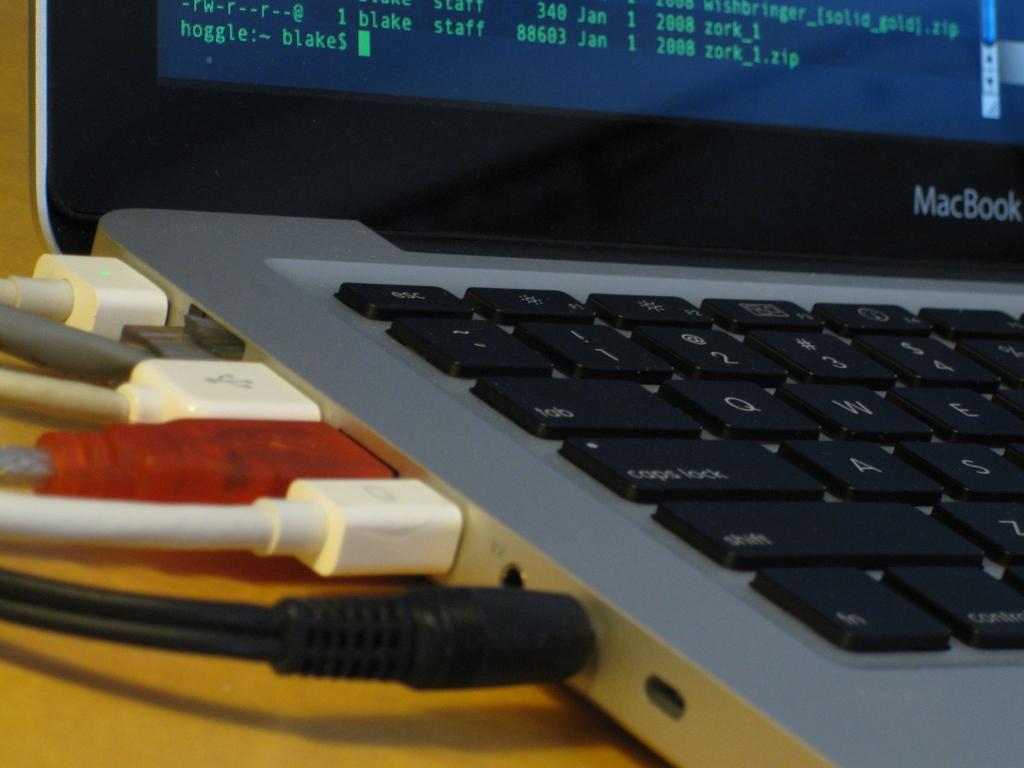What brand is the laptop?
Provide a succinct answer. Macbook. What kind of laptop is this?
Make the answer very short. Macbook. 